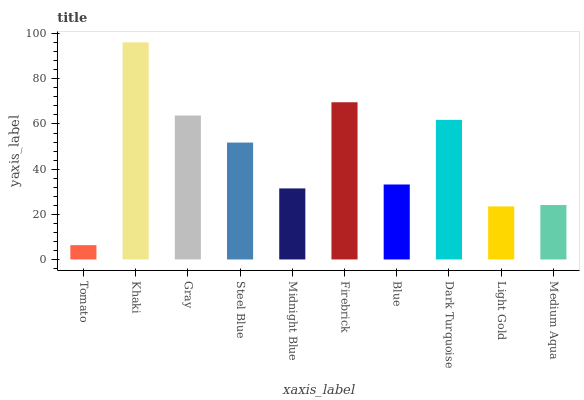Is Tomato the minimum?
Answer yes or no. Yes. Is Khaki the maximum?
Answer yes or no. Yes. Is Gray the minimum?
Answer yes or no. No. Is Gray the maximum?
Answer yes or no. No. Is Khaki greater than Gray?
Answer yes or no. Yes. Is Gray less than Khaki?
Answer yes or no. Yes. Is Gray greater than Khaki?
Answer yes or no. No. Is Khaki less than Gray?
Answer yes or no. No. Is Steel Blue the high median?
Answer yes or no. Yes. Is Blue the low median?
Answer yes or no. Yes. Is Gray the high median?
Answer yes or no. No. Is Tomato the low median?
Answer yes or no. No. 